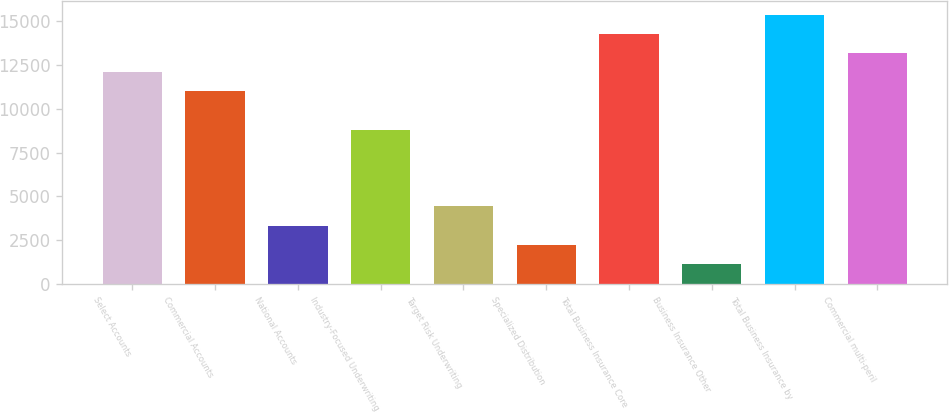Convert chart to OTSL. <chart><loc_0><loc_0><loc_500><loc_500><bar_chart><fcel>Select Accounts<fcel>Commercial Accounts<fcel>National Accounts<fcel>Industry-Focused Underwriting<fcel>Target Risk Underwriting<fcel>Specialized Distribution<fcel>Total Business Insurance Core<fcel>Business Insurance Other<fcel>Total Business Insurance by<fcel>Commercial multi-peril<nl><fcel>12094.3<fcel>10999<fcel>3331.9<fcel>8808.4<fcel>4427.2<fcel>2236.6<fcel>14284.9<fcel>1141.3<fcel>15380.2<fcel>13189.6<nl></chart> 